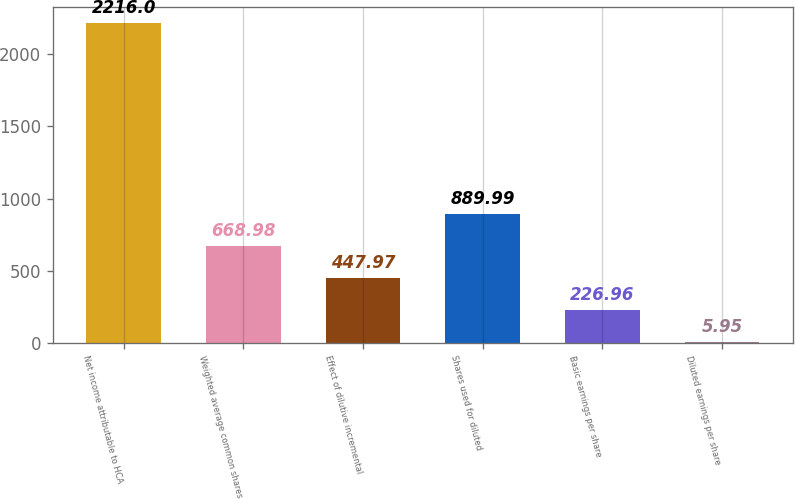<chart> <loc_0><loc_0><loc_500><loc_500><bar_chart><fcel>Net income attributable to HCA<fcel>Weighted average common shares<fcel>Effect of dilutive incremental<fcel>Shares used for diluted<fcel>Basic earnings per share<fcel>Diluted earnings per share<nl><fcel>2216<fcel>668.98<fcel>447.97<fcel>889.99<fcel>226.96<fcel>5.95<nl></chart> 